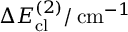Convert formula to latex. <formula><loc_0><loc_0><loc_500><loc_500>\Delta E _ { c l } ^ { ( 2 ) } / \, c m ^ { - 1 }</formula> 